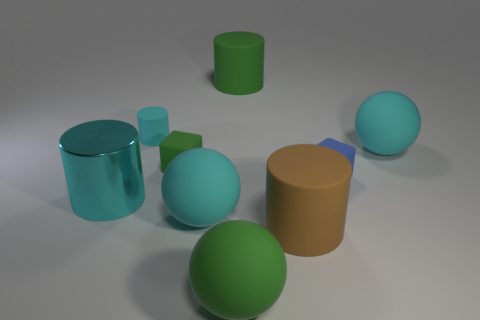There is a small object right of the large matte cylinder in front of the small rubber object behind the small green object; what is its color?
Provide a succinct answer. Blue. Do the large shiny thing and the small blue object have the same shape?
Give a very brief answer. No. There is a big cylinder that is made of the same material as the big brown object; what is its color?
Give a very brief answer. Green. What number of objects are big matte objects that are left of the brown rubber thing or tiny cyan objects?
Make the answer very short. 4. There is a cyan matte sphere that is to the left of the large brown rubber object; what is its size?
Your answer should be very brief. Large. Is the size of the cyan matte cylinder the same as the cyan ball that is in front of the shiny cylinder?
Offer a very short reply. No. There is a rubber block that is in front of the green matte cube that is to the right of the cyan shiny cylinder; what color is it?
Provide a short and direct response. Blue. Is the number of big yellow matte things the same as the number of small blue cubes?
Offer a terse response. No. How many other objects are there of the same color as the large metallic object?
Keep it short and to the point. 3. The blue rubber object is what size?
Give a very brief answer. Small. 